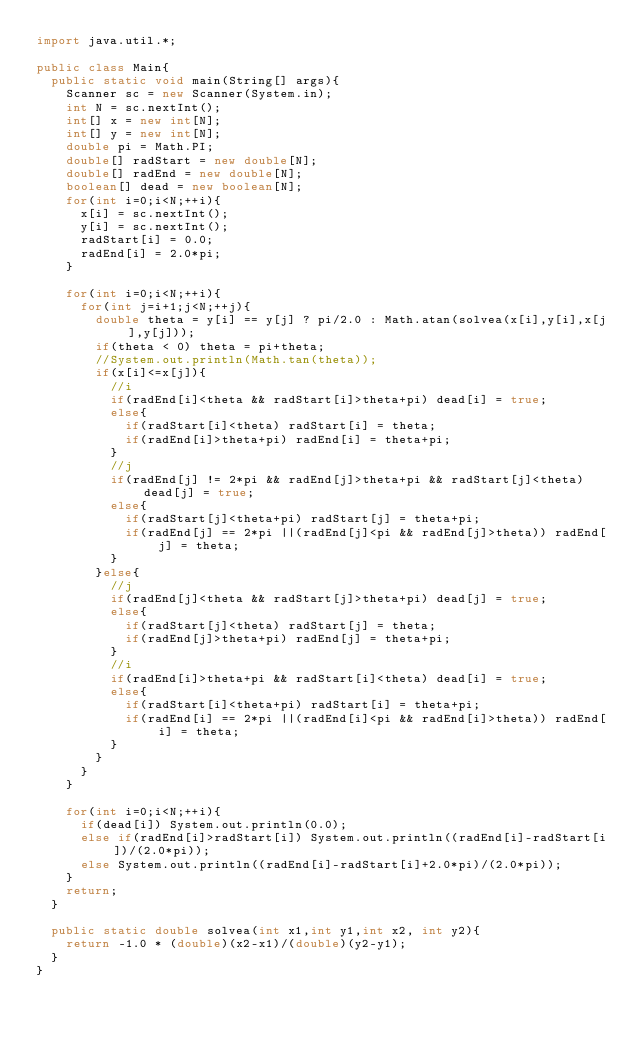Convert code to text. <code><loc_0><loc_0><loc_500><loc_500><_Java_>import java.util.*;

public class Main{	
	public static void main(String[] args){
		Scanner sc = new Scanner(System.in);
		int N = sc.nextInt();
		int[] x = new int[N];
		int[] y = new int[N];
		double pi = Math.PI;
		double[] radStart = new double[N];
		double[] radEnd = new double[N];
		boolean[] dead = new boolean[N];
		for(int i=0;i<N;++i){
			x[i] = sc.nextInt();
			y[i] = sc.nextInt();
			radStart[i] = 0.0;
			radEnd[i] = 2.0*pi;
		}
		
		for(int i=0;i<N;++i){
			for(int j=i+1;j<N;++j){
				double theta = y[i] == y[j] ? pi/2.0 : Math.atan(solvea(x[i],y[i],x[j],y[j]));
				if(theta < 0) theta = pi+theta;
				//System.out.println(Math.tan(theta));
				if(x[i]<=x[j]){
					//i
					if(radEnd[i]<theta && radStart[i]>theta+pi) dead[i] = true;
					else{
						if(radStart[i]<theta) radStart[i] = theta;
						if(radEnd[i]>theta+pi) radEnd[i] = theta+pi;
					}
					//j
					if(radEnd[j] != 2*pi && radEnd[j]>theta+pi && radStart[j]<theta) dead[j] = true;
					else{
						if(radStart[j]<theta+pi) radStart[j] = theta+pi;
						if(radEnd[j] == 2*pi ||(radEnd[j]<pi && radEnd[j]>theta)) radEnd[j] = theta;
					}
				}else{
					//j
					if(radEnd[j]<theta && radStart[j]>theta+pi) dead[j] = true;
					else{
						if(radStart[j]<theta) radStart[j] = theta;
						if(radEnd[j]>theta+pi) radEnd[j] = theta+pi;
					}
					//i
					if(radEnd[i]>theta+pi && radStart[i]<theta) dead[i] = true;
					else{
						if(radStart[i]<theta+pi) radStart[i] = theta+pi;
						if(radEnd[i] == 2*pi ||(radEnd[i]<pi && radEnd[i]>theta)) radEnd[i] = theta;
					}
				}
			}
		}

		for(int i=0;i<N;++i){
			if(dead[i]) System.out.println(0.0);
			else if(radEnd[i]>radStart[i]) System.out.println((radEnd[i]-radStart[i])/(2.0*pi)); 
			else System.out.println((radEnd[i]-radStart[i]+2.0*pi)/(2.0*pi));
		}
		return;
	}
	
	public static double solvea(int x1,int y1,int x2, int y2){
		return -1.0 * (double)(x2-x1)/(double)(y2-y1);
	}
}</code> 